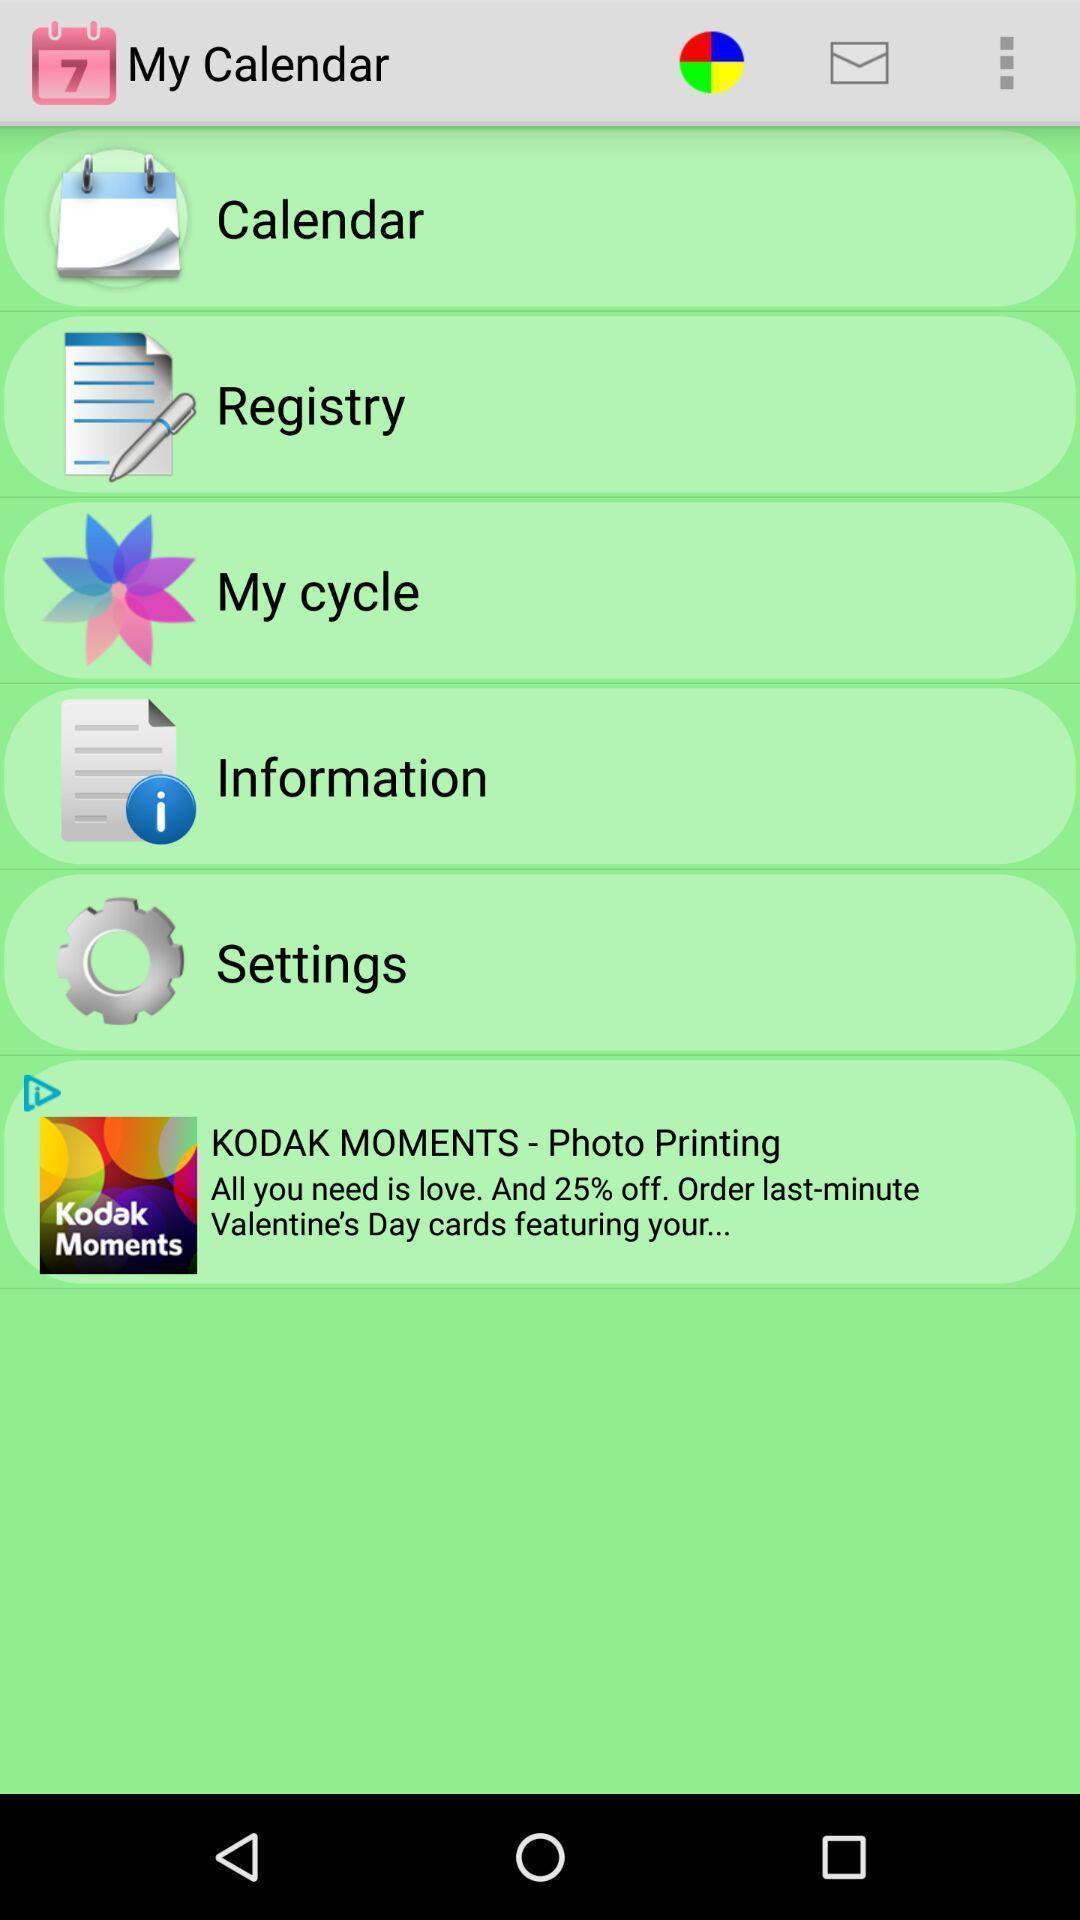Please provide a description for this image. Page displaying various options in calendar app. 